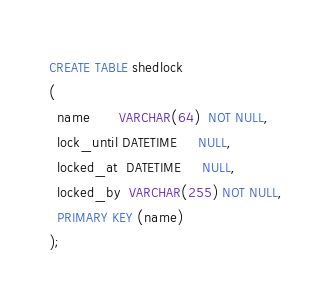<code> <loc_0><loc_0><loc_500><loc_500><_SQL_>CREATE TABLE shedlock
(
  name       VARCHAR(64)  NOT NULL,
  lock_until DATETIME     NULL,
  locked_at  DATETIME     NULL,
  locked_by  VARCHAR(255) NOT NULL,
  PRIMARY KEY (name)
);

</code> 